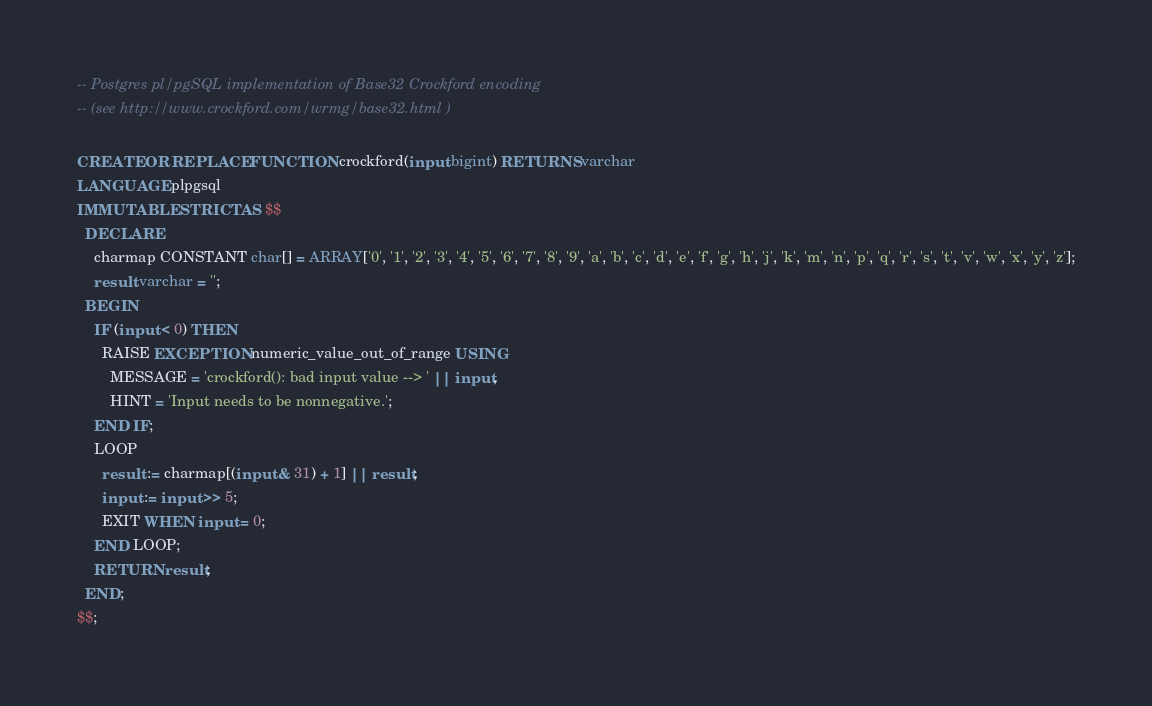<code> <loc_0><loc_0><loc_500><loc_500><_SQL_>-- Postgres pl/pgSQL implementation of Base32 Crockford encoding
-- (see http://www.crockford.com/wrmg/base32.html )

CREATE OR REPLACE FUNCTION crockford(input bigint) RETURNS varchar
LANGUAGE plpgsql
IMMUTABLE STRICT AS $$
  DECLARE
    charmap CONSTANT char[] = ARRAY['0', '1', '2', '3', '4', '5', '6', '7', '8', '9', 'a', 'b', 'c', 'd', 'e', 'f', 'g', 'h', 'j', 'k', 'm', 'n', 'p', 'q', 'r', 's', 't', 'v', 'w', 'x', 'y', 'z'];
    result varchar = '';
  BEGIN
    IF (input < 0) THEN
      RAISE EXCEPTION numeric_value_out_of_range USING
        MESSAGE = 'crockford(): bad input value --> ' || input,
        HINT = 'Input needs to be nonnegative.';
    END IF;
    LOOP
      result := charmap[(input & 31) + 1] || result;
      input := input >> 5;
      EXIT WHEN input = 0;
    END LOOP;
    RETURN result;
  END;
$$;
</code> 